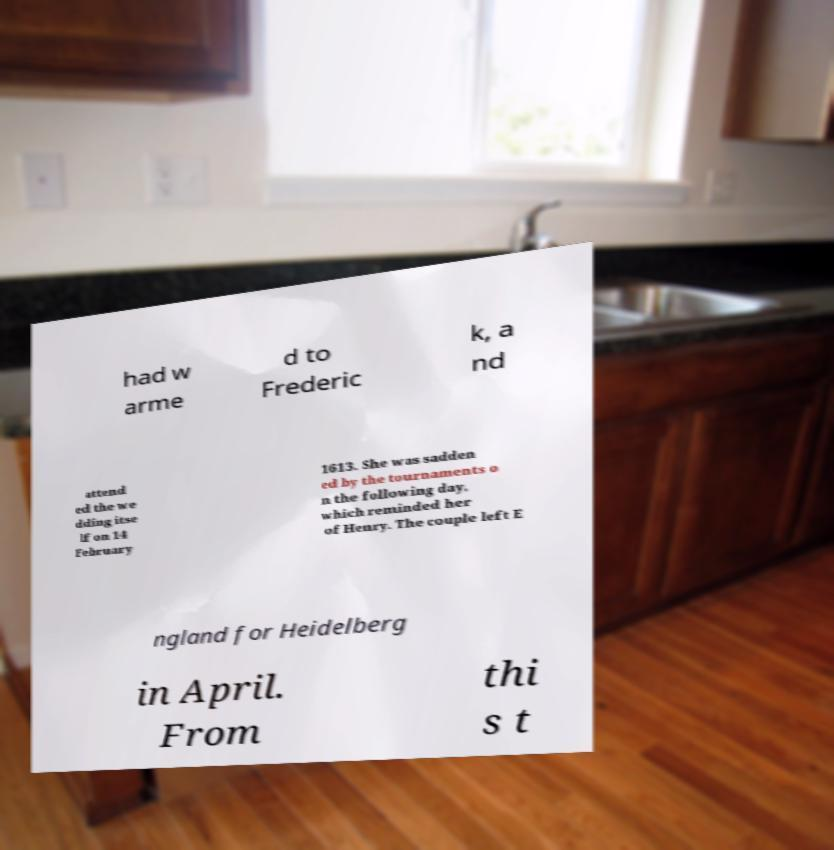What messages or text are displayed in this image? I need them in a readable, typed format. had w arme d to Frederic k, a nd attend ed the we dding itse lf on 14 February 1613. She was sadden ed by the tournaments o n the following day, which reminded her of Henry. The couple left E ngland for Heidelberg in April. From thi s t 